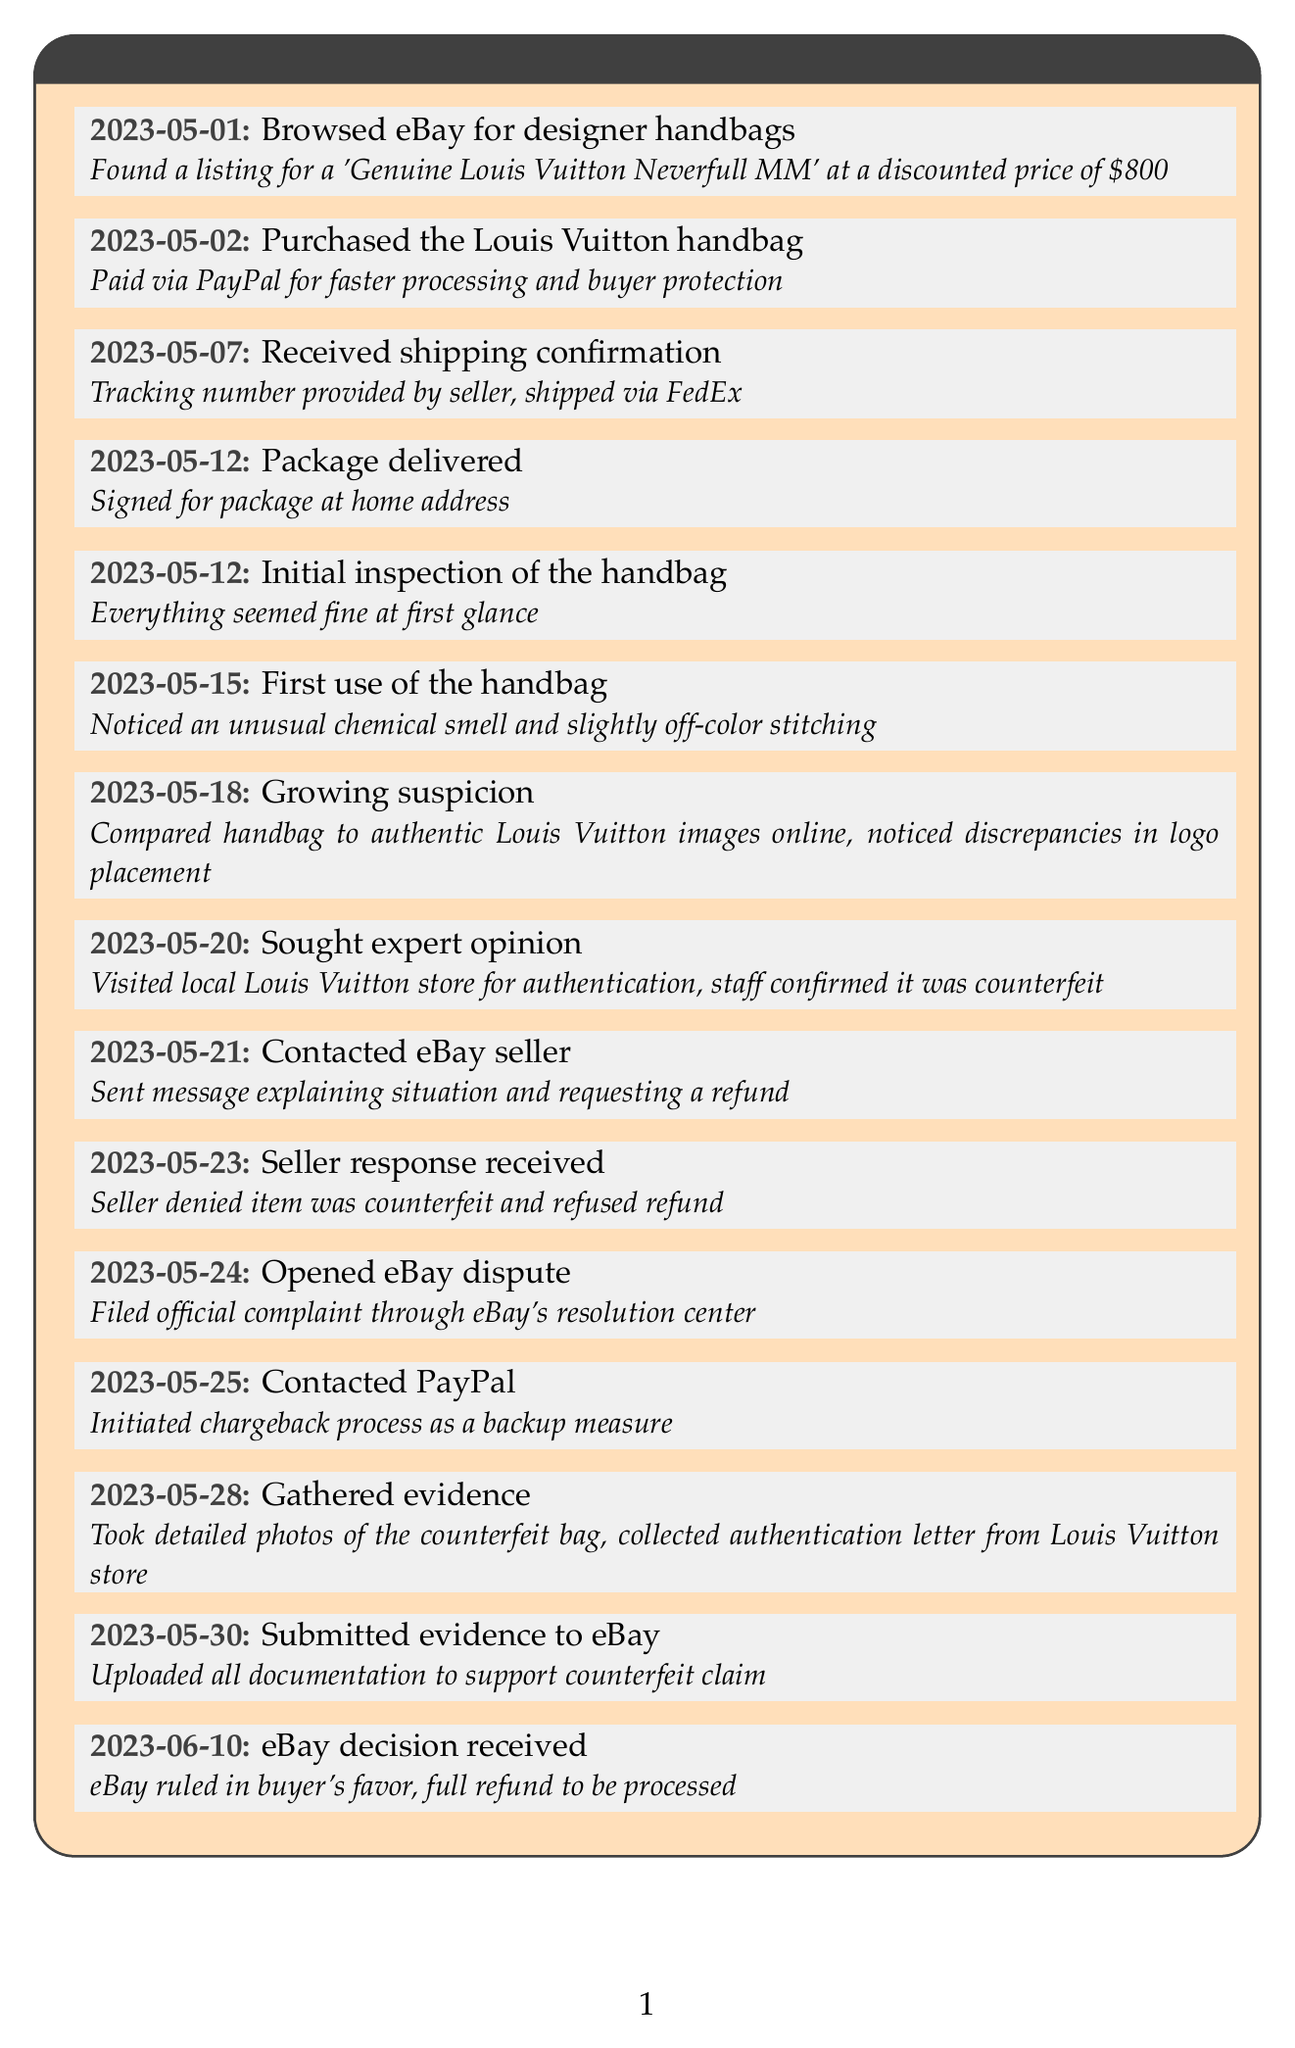What date was the handbag purchased? The handbag was purchased on May 2, 2023.
Answer: May 2, 2023 What was the paid amount for the handbag? The handbag was purchased for a discounted price of $800.
Answer: $800 What issue arose during the first use of the handbag? The buyer noticed an unusual chemical smell and slightly off-color stitching.
Answer: Unusual chemical smell What did the buyer do on May 24, 2023? The buyer opened an eBay dispute by filing an official complaint.
Answer: Opened eBay dispute What was the final decision made by eBay? eBay ruled in the buyer's favor and processed a full refund.
Answer: Full refund What reason did the seller give for denying the refund? The seller denied the item was counterfeit and refused the refund.
Answer: Denied item was counterfeit How long after the package was delivered did the buyer seek expert opinion? The buyer sought expert opinion eight days after delivery.
Answer: Eight days What is included in the buyer's note? The buyer's note discusses their experience with the counterfeit handbag purchase and advises caution.
Answer: Experience and caution advice 